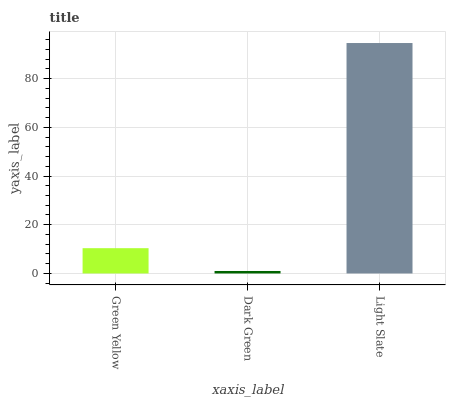Is Dark Green the minimum?
Answer yes or no. Yes. Is Light Slate the maximum?
Answer yes or no. Yes. Is Light Slate the minimum?
Answer yes or no. No. Is Dark Green the maximum?
Answer yes or no. No. Is Light Slate greater than Dark Green?
Answer yes or no. Yes. Is Dark Green less than Light Slate?
Answer yes or no. Yes. Is Dark Green greater than Light Slate?
Answer yes or no. No. Is Light Slate less than Dark Green?
Answer yes or no. No. Is Green Yellow the high median?
Answer yes or no. Yes. Is Green Yellow the low median?
Answer yes or no. Yes. Is Dark Green the high median?
Answer yes or no. No. Is Dark Green the low median?
Answer yes or no. No. 